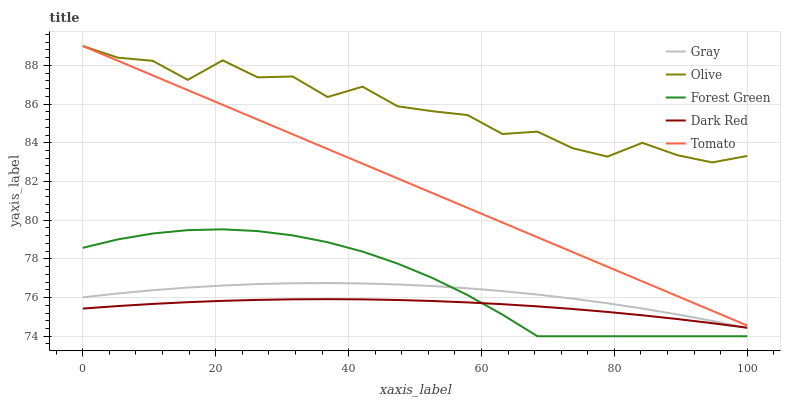Does Dark Red have the minimum area under the curve?
Answer yes or no. Yes. Does Olive have the maximum area under the curve?
Answer yes or no. Yes. Does Gray have the minimum area under the curve?
Answer yes or no. No. Does Gray have the maximum area under the curve?
Answer yes or no. No. Is Tomato the smoothest?
Answer yes or no. Yes. Is Olive the roughest?
Answer yes or no. Yes. Is Gray the smoothest?
Answer yes or no. No. Is Gray the roughest?
Answer yes or no. No. Does Forest Green have the lowest value?
Answer yes or no. Yes. Does Gray have the lowest value?
Answer yes or no. No. Does Tomato have the highest value?
Answer yes or no. Yes. Does Gray have the highest value?
Answer yes or no. No. Is Gray less than Olive?
Answer yes or no. Yes. Is Olive greater than Forest Green?
Answer yes or no. Yes. Does Gray intersect Forest Green?
Answer yes or no. Yes. Is Gray less than Forest Green?
Answer yes or no. No. Is Gray greater than Forest Green?
Answer yes or no. No. Does Gray intersect Olive?
Answer yes or no. No. 